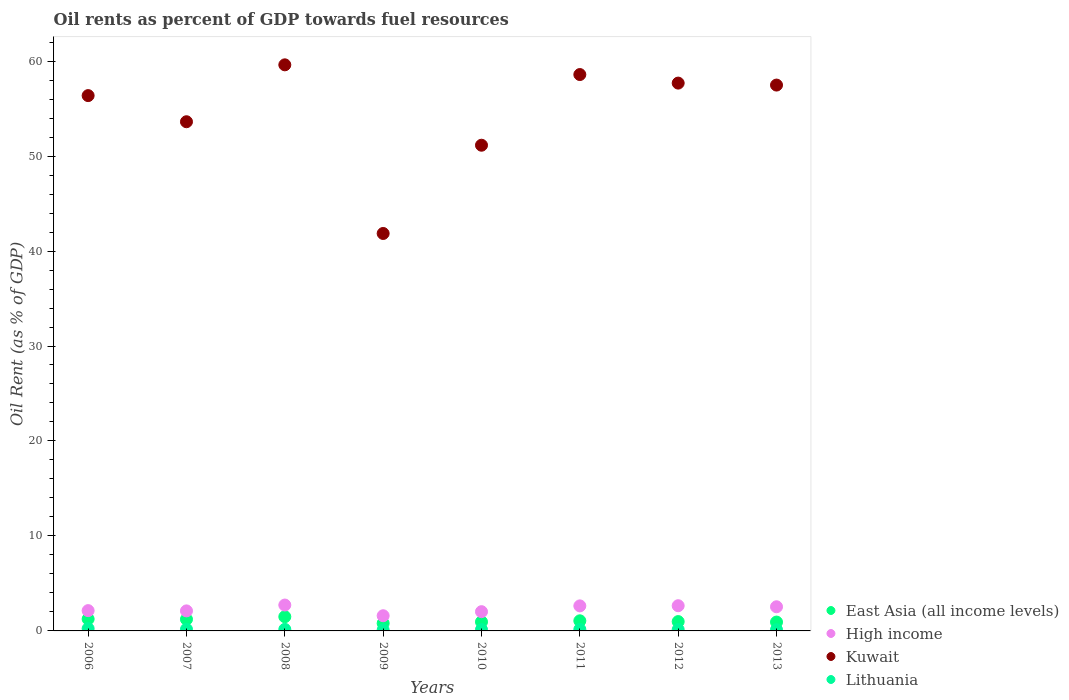Is the number of dotlines equal to the number of legend labels?
Your answer should be very brief. Yes. What is the oil rent in High income in 2010?
Your response must be concise. 2.03. Across all years, what is the maximum oil rent in East Asia (all income levels)?
Your answer should be compact. 1.5. Across all years, what is the minimum oil rent in Kuwait?
Your answer should be very brief. 41.85. In which year was the oil rent in East Asia (all income levels) maximum?
Offer a very short reply. 2008. In which year was the oil rent in Kuwait minimum?
Your answer should be very brief. 2009. What is the total oil rent in East Asia (all income levels) in the graph?
Give a very brief answer. 8.71. What is the difference between the oil rent in High income in 2008 and that in 2012?
Offer a very short reply. 0.07. What is the difference between the oil rent in East Asia (all income levels) in 2006 and the oil rent in High income in 2009?
Provide a succinct answer. -0.35. What is the average oil rent in High income per year?
Provide a succinct answer. 2.3. In the year 2008, what is the difference between the oil rent in Lithuania and oil rent in Kuwait?
Provide a short and direct response. -59.44. What is the ratio of the oil rent in High income in 2010 to that in 2011?
Your answer should be compact. 0.77. Is the oil rent in Lithuania in 2007 less than that in 2011?
Your answer should be very brief. No. What is the difference between the highest and the second highest oil rent in East Asia (all income levels)?
Provide a short and direct response. 0.24. What is the difference between the highest and the lowest oil rent in High income?
Keep it short and to the point. 1.13. Is it the case that in every year, the sum of the oil rent in Lithuania and oil rent in Kuwait  is greater than the sum of oil rent in East Asia (all income levels) and oil rent in High income?
Offer a terse response. No. Is it the case that in every year, the sum of the oil rent in East Asia (all income levels) and oil rent in Kuwait  is greater than the oil rent in Lithuania?
Ensure brevity in your answer.  Yes. Does the oil rent in Kuwait monotonically increase over the years?
Make the answer very short. No. Is the oil rent in Lithuania strictly greater than the oil rent in Kuwait over the years?
Provide a short and direct response. No. Is the oil rent in Lithuania strictly less than the oil rent in High income over the years?
Your answer should be very brief. Yes. How many dotlines are there?
Give a very brief answer. 4. How many years are there in the graph?
Offer a terse response. 8. Are the values on the major ticks of Y-axis written in scientific E-notation?
Your response must be concise. No. Does the graph contain grids?
Provide a short and direct response. No. How are the legend labels stacked?
Give a very brief answer. Vertical. What is the title of the graph?
Give a very brief answer. Oil rents as percent of GDP towards fuel resources. What is the label or title of the X-axis?
Ensure brevity in your answer.  Years. What is the label or title of the Y-axis?
Ensure brevity in your answer.  Oil Rent (as % of GDP). What is the Oil Rent (as % of GDP) in East Asia (all income levels) in 2006?
Your answer should be very brief. 1.25. What is the Oil Rent (as % of GDP) of High income in 2006?
Keep it short and to the point. 2.14. What is the Oil Rent (as % of GDP) of Kuwait in 2006?
Your answer should be compact. 56.37. What is the Oil Rent (as % of GDP) of Lithuania in 2006?
Offer a very short reply. 0.24. What is the Oil Rent (as % of GDP) in East Asia (all income levels) in 2007?
Your response must be concise. 1.22. What is the Oil Rent (as % of GDP) of High income in 2007?
Provide a short and direct response. 2.11. What is the Oil Rent (as % of GDP) in Kuwait in 2007?
Offer a very short reply. 53.61. What is the Oil Rent (as % of GDP) in Lithuania in 2007?
Your answer should be very brief. 0.17. What is the Oil Rent (as % of GDP) in East Asia (all income levels) in 2008?
Offer a very short reply. 1.5. What is the Oil Rent (as % of GDP) in High income in 2008?
Your answer should be compact. 2.73. What is the Oil Rent (as % of GDP) of Kuwait in 2008?
Your answer should be very brief. 59.61. What is the Oil Rent (as % of GDP) of Lithuania in 2008?
Offer a very short reply. 0.16. What is the Oil Rent (as % of GDP) in East Asia (all income levels) in 2009?
Offer a terse response. 0.8. What is the Oil Rent (as % of GDP) of High income in 2009?
Ensure brevity in your answer.  1.6. What is the Oil Rent (as % of GDP) of Kuwait in 2009?
Offer a very short reply. 41.85. What is the Oil Rent (as % of GDP) of Lithuania in 2009?
Offer a terse response. 0.11. What is the Oil Rent (as % of GDP) in East Asia (all income levels) in 2010?
Your response must be concise. 0.95. What is the Oil Rent (as % of GDP) in High income in 2010?
Provide a short and direct response. 2.03. What is the Oil Rent (as % of GDP) of Kuwait in 2010?
Your answer should be very brief. 51.14. What is the Oil Rent (as % of GDP) of Lithuania in 2010?
Your answer should be compact. 0.14. What is the Oil Rent (as % of GDP) of East Asia (all income levels) in 2011?
Your response must be concise. 1.07. What is the Oil Rent (as % of GDP) of High income in 2011?
Keep it short and to the point. 2.64. What is the Oil Rent (as % of GDP) of Kuwait in 2011?
Make the answer very short. 58.58. What is the Oil Rent (as % of GDP) of Lithuania in 2011?
Offer a terse response. 0.16. What is the Oil Rent (as % of GDP) of East Asia (all income levels) in 2012?
Make the answer very short. 0.98. What is the Oil Rent (as % of GDP) of High income in 2012?
Provide a succinct answer. 2.65. What is the Oil Rent (as % of GDP) of Kuwait in 2012?
Give a very brief answer. 57.68. What is the Oil Rent (as % of GDP) in Lithuania in 2012?
Your answer should be compact. 0.14. What is the Oil Rent (as % of GDP) in East Asia (all income levels) in 2013?
Your answer should be very brief. 0.93. What is the Oil Rent (as % of GDP) in High income in 2013?
Keep it short and to the point. 2.54. What is the Oil Rent (as % of GDP) in Kuwait in 2013?
Make the answer very short. 57.47. What is the Oil Rent (as % of GDP) of Lithuania in 2013?
Offer a terse response. 0.13. Across all years, what is the maximum Oil Rent (as % of GDP) in East Asia (all income levels)?
Make the answer very short. 1.5. Across all years, what is the maximum Oil Rent (as % of GDP) in High income?
Give a very brief answer. 2.73. Across all years, what is the maximum Oil Rent (as % of GDP) in Kuwait?
Offer a very short reply. 59.61. Across all years, what is the maximum Oil Rent (as % of GDP) in Lithuania?
Keep it short and to the point. 0.24. Across all years, what is the minimum Oil Rent (as % of GDP) of East Asia (all income levels)?
Your answer should be compact. 0.8. Across all years, what is the minimum Oil Rent (as % of GDP) in High income?
Provide a short and direct response. 1.6. Across all years, what is the minimum Oil Rent (as % of GDP) in Kuwait?
Make the answer very short. 41.85. Across all years, what is the minimum Oil Rent (as % of GDP) of Lithuania?
Give a very brief answer. 0.11. What is the total Oil Rent (as % of GDP) in East Asia (all income levels) in the graph?
Your answer should be very brief. 8.71. What is the total Oil Rent (as % of GDP) in High income in the graph?
Make the answer very short. 18.43. What is the total Oil Rent (as % of GDP) of Kuwait in the graph?
Offer a very short reply. 436.31. What is the total Oil Rent (as % of GDP) in Lithuania in the graph?
Offer a terse response. 1.25. What is the difference between the Oil Rent (as % of GDP) in East Asia (all income levels) in 2006 and that in 2007?
Your answer should be very brief. 0.03. What is the difference between the Oil Rent (as % of GDP) in High income in 2006 and that in 2007?
Keep it short and to the point. 0.03. What is the difference between the Oil Rent (as % of GDP) in Kuwait in 2006 and that in 2007?
Your answer should be very brief. 2.75. What is the difference between the Oil Rent (as % of GDP) in Lithuania in 2006 and that in 2007?
Provide a succinct answer. 0.07. What is the difference between the Oil Rent (as % of GDP) of East Asia (all income levels) in 2006 and that in 2008?
Provide a short and direct response. -0.24. What is the difference between the Oil Rent (as % of GDP) in High income in 2006 and that in 2008?
Offer a very short reply. -0.59. What is the difference between the Oil Rent (as % of GDP) in Kuwait in 2006 and that in 2008?
Offer a terse response. -3.24. What is the difference between the Oil Rent (as % of GDP) in Lithuania in 2006 and that in 2008?
Keep it short and to the point. 0.08. What is the difference between the Oil Rent (as % of GDP) in East Asia (all income levels) in 2006 and that in 2009?
Make the answer very short. 0.45. What is the difference between the Oil Rent (as % of GDP) of High income in 2006 and that in 2009?
Give a very brief answer. 0.54. What is the difference between the Oil Rent (as % of GDP) of Kuwait in 2006 and that in 2009?
Provide a succinct answer. 14.52. What is the difference between the Oil Rent (as % of GDP) in Lithuania in 2006 and that in 2009?
Provide a succinct answer. 0.14. What is the difference between the Oil Rent (as % of GDP) in East Asia (all income levels) in 2006 and that in 2010?
Give a very brief answer. 0.3. What is the difference between the Oil Rent (as % of GDP) of High income in 2006 and that in 2010?
Offer a terse response. 0.11. What is the difference between the Oil Rent (as % of GDP) of Kuwait in 2006 and that in 2010?
Make the answer very short. 5.22. What is the difference between the Oil Rent (as % of GDP) in Lithuania in 2006 and that in 2010?
Your answer should be very brief. 0.1. What is the difference between the Oil Rent (as % of GDP) in East Asia (all income levels) in 2006 and that in 2011?
Your answer should be compact. 0.19. What is the difference between the Oil Rent (as % of GDP) of High income in 2006 and that in 2011?
Your answer should be very brief. -0.5. What is the difference between the Oil Rent (as % of GDP) in Kuwait in 2006 and that in 2011?
Provide a succinct answer. -2.22. What is the difference between the Oil Rent (as % of GDP) of Lithuania in 2006 and that in 2011?
Offer a very short reply. 0.08. What is the difference between the Oil Rent (as % of GDP) in East Asia (all income levels) in 2006 and that in 2012?
Keep it short and to the point. 0.27. What is the difference between the Oil Rent (as % of GDP) in High income in 2006 and that in 2012?
Give a very brief answer. -0.52. What is the difference between the Oil Rent (as % of GDP) in Kuwait in 2006 and that in 2012?
Your response must be concise. -1.32. What is the difference between the Oil Rent (as % of GDP) in Lithuania in 2006 and that in 2012?
Offer a terse response. 0.1. What is the difference between the Oil Rent (as % of GDP) in East Asia (all income levels) in 2006 and that in 2013?
Your answer should be compact. 0.32. What is the difference between the Oil Rent (as % of GDP) of High income in 2006 and that in 2013?
Offer a very short reply. -0.4. What is the difference between the Oil Rent (as % of GDP) of Kuwait in 2006 and that in 2013?
Provide a short and direct response. -1.11. What is the difference between the Oil Rent (as % of GDP) of Lithuania in 2006 and that in 2013?
Give a very brief answer. 0.12. What is the difference between the Oil Rent (as % of GDP) of East Asia (all income levels) in 2007 and that in 2008?
Your answer should be very brief. -0.27. What is the difference between the Oil Rent (as % of GDP) of High income in 2007 and that in 2008?
Ensure brevity in your answer.  -0.62. What is the difference between the Oil Rent (as % of GDP) in Kuwait in 2007 and that in 2008?
Provide a succinct answer. -5.99. What is the difference between the Oil Rent (as % of GDP) in Lithuania in 2007 and that in 2008?
Make the answer very short. 0.01. What is the difference between the Oil Rent (as % of GDP) of East Asia (all income levels) in 2007 and that in 2009?
Give a very brief answer. 0.42. What is the difference between the Oil Rent (as % of GDP) in High income in 2007 and that in 2009?
Offer a terse response. 0.51. What is the difference between the Oil Rent (as % of GDP) in Kuwait in 2007 and that in 2009?
Provide a succinct answer. 11.76. What is the difference between the Oil Rent (as % of GDP) in Lithuania in 2007 and that in 2009?
Make the answer very short. 0.07. What is the difference between the Oil Rent (as % of GDP) in East Asia (all income levels) in 2007 and that in 2010?
Make the answer very short. 0.27. What is the difference between the Oil Rent (as % of GDP) of High income in 2007 and that in 2010?
Your answer should be compact. 0.08. What is the difference between the Oil Rent (as % of GDP) of Kuwait in 2007 and that in 2010?
Keep it short and to the point. 2.47. What is the difference between the Oil Rent (as % of GDP) in Lithuania in 2007 and that in 2010?
Offer a terse response. 0.03. What is the difference between the Oil Rent (as % of GDP) of East Asia (all income levels) in 2007 and that in 2011?
Make the answer very short. 0.16. What is the difference between the Oil Rent (as % of GDP) of High income in 2007 and that in 2011?
Offer a very short reply. -0.53. What is the difference between the Oil Rent (as % of GDP) in Kuwait in 2007 and that in 2011?
Keep it short and to the point. -4.97. What is the difference between the Oil Rent (as % of GDP) in Lithuania in 2007 and that in 2011?
Keep it short and to the point. 0.01. What is the difference between the Oil Rent (as % of GDP) of East Asia (all income levels) in 2007 and that in 2012?
Your answer should be compact. 0.24. What is the difference between the Oil Rent (as % of GDP) in High income in 2007 and that in 2012?
Make the answer very short. -0.54. What is the difference between the Oil Rent (as % of GDP) in Kuwait in 2007 and that in 2012?
Provide a short and direct response. -4.07. What is the difference between the Oil Rent (as % of GDP) in Lithuania in 2007 and that in 2012?
Ensure brevity in your answer.  0.03. What is the difference between the Oil Rent (as % of GDP) in East Asia (all income levels) in 2007 and that in 2013?
Keep it short and to the point. 0.29. What is the difference between the Oil Rent (as % of GDP) of High income in 2007 and that in 2013?
Offer a terse response. -0.43. What is the difference between the Oil Rent (as % of GDP) in Kuwait in 2007 and that in 2013?
Your answer should be compact. -3.86. What is the difference between the Oil Rent (as % of GDP) of Lithuania in 2007 and that in 2013?
Make the answer very short. 0.05. What is the difference between the Oil Rent (as % of GDP) in East Asia (all income levels) in 2008 and that in 2009?
Give a very brief answer. 0.69. What is the difference between the Oil Rent (as % of GDP) in High income in 2008 and that in 2009?
Give a very brief answer. 1.13. What is the difference between the Oil Rent (as % of GDP) of Kuwait in 2008 and that in 2009?
Provide a short and direct response. 17.76. What is the difference between the Oil Rent (as % of GDP) of Lithuania in 2008 and that in 2009?
Your answer should be very brief. 0.06. What is the difference between the Oil Rent (as % of GDP) in East Asia (all income levels) in 2008 and that in 2010?
Offer a very short reply. 0.54. What is the difference between the Oil Rent (as % of GDP) of High income in 2008 and that in 2010?
Offer a terse response. 0.7. What is the difference between the Oil Rent (as % of GDP) of Kuwait in 2008 and that in 2010?
Your answer should be compact. 8.46. What is the difference between the Oil Rent (as % of GDP) of Lithuania in 2008 and that in 2010?
Your answer should be very brief. 0.02. What is the difference between the Oil Rent (as % of GDP) in East Asia (all income levels) in 2008 and that in 2011?
Keep it short and to the point. 0.43. What is the difference between the Oil Rent (as % of GDP) in High income in 2008 and that in 2011?
Your answer should be compact. 0.09. What is the difference between the Oil Rent (as % of GDP) in Kuwait in 2008 and that in 2011?
Your response must be concise. 1.02. What is the difference between the Oil Rent (as % of GDP) in Lithuania in 2008 and that in 2011?
Your answer should be compact. 0. What is the difference between the Oil Rent (as % of GDP) of East Asia (all income levels) in 2008 and that in 2012?
Your answer should be very brief. 0.51. What is the difference between the Oil Rent (as % of GDP) of High income in 2008 and that in 2012?
Ensure brevity in your answer.  0.07. What is the difference between the Oil Rent (as % of GDP) of Kuwait in 2008 and that in 2012?
Your answer should be compact. 1.92. What is the difference between the Oil Rent (as % of GDP) of Lithuania in 2008 and that in 2012?
Ensure brevity in your answer.  0.02. What is the difference between the Oil Rent (as % of GDP) in East Asia (all income levels) in 2008 and that in 2013?
Your response must be concise. 0.56. What is the difference between the Oil Rent (as % of GDP) of High income in 2008 and that in 2013?
Give a very brief answer. 0.18. What is the difference between the Oil Rent (as % of GDP) in Kuwait in 2008 and that in 2013?
Your answer should be compact. 2.13. What is the difference between the Oil Rent (as % of GDP) in Lithuania in 2008 and that in 2013?
Ensure brevity in your answer.  0.04. What is the difference between the Oil Rent (as % of GDP) of East Asia (all income levels) in 2009 and that in 2010?
Make the answer very short. -0.15. What is the difference between the Oil Rent (as % of GDP) of High income in 2009 and that in 2010?
Ensure brevity in your answer.  -0.43. What is the difference between the Oil Rent (as % of GDP) in Kuwait in 2009 and that in 2010?
Ensure brevity in your answer.  -9.29. What is the difference between the Oil Rent (as % of GDP) in Lithuania in 2009 and that in 2010?
Your answer should be very brief. -0.04. What is the difference between the Oil Rent (as % of GDP) of East Asia (all income levels) in 2009 and that in 2011?
Make the answer very short. -0.26. What is the difference between the Oil Rent (as % of GDP) of High income in 2009 and that in 2011?
Your response must be concise. -1.04. What is the difference between the Oil Rent (as % of GDP) of Kuwait in 2009 and that in 2011?
Provide a short and direct response. -16.73. What is the difference between the Oil Rent (as % of GDP) in Lithuania in 2009 and that in 2011?
Provide a short and direct response. -0.06. What is the difference between the Oil Rent (as % of GDP) in East Asia (all income levels) in 2009 and that in 2012?
Make the answer very short. -0.18. What is the difference between the Oil Rent (as % of GDP) of High income in 2009 and that in 2012?
Keep it short and to the point. -1.05. What is the difference between the Oil Rent (as % of GDP) in Kuwait in 2009 and that in 2012?
Your answer should be compact. -15.83. What is the difference between the Oil Rent (as % of GDP) of Lithuania in 2009 and that in 2012?
Keep it short and to the point. -0.04. What is the difference between the Oil Rent (as % of GDP) in East Asia (all income levels) in 2009 and that in 2013?
Ensure brevity in your answer.  -0.13. What is the difference between the Oil Rent (as % of GDP) of High income in 2009 and that in 2013?
Provide a short and direct response. -0.94. What is the difference between the Oil Rent (as % of GDP) of Kuwait in 2009 and that in 2013?
Ensure brevity in your answer.  -15.63. What is the difference between the Oil Rent (as % of GDP) of Lithuania in 2009 and that in 2013?
Give a very brief answer. -0.02. What is the difference between the Oil Rent (as % of GDP) of East Asia (all income levels) in 2010 and that in 2011?
Your answer should be compact. -0.11. What is the difference between the Oil Rent (as % of GDP) of High income in 2010 and that in 2011?
Keep it short and to the point. -0.61. What is the difference between the Oil Rent (as % of GDP) of Kuwait in 2010 and that in 2011?
Give a very brief answer. -7.44. What is the difference between the Oil Rent (as % of GDP) in Lithuania in 2010 and that in 2011?
Keep it short and to the point. -0.02. What is the difference between the Oil Rent (as % of GDP) in East Asia (all income levels) in 2010 and that in 2012?
Make the answer very short. -0.03. What is the difference between the Oil Rent (as % of GDP) in High income in 2010 and that in 2012?
Provide a short and direct response. -0.63. What is the difference between the Oil Rent (as % of GDP) of Kuwait in 2010 and that in 2012?
Provide a succinct answer. -6.54. What is the difference between the Oil Rent (as % of GDP) in Lithuania in 2010 and that in 2012?
Keep it short and to the point. -0. What is the difference between the Oil Rent (as % of GDP) of East Asia (all income levels) in 2010 and that in 2013?
Your answer should be compact. 0.02. What is the difference between the Oil Rent (as % of GDP) of High income in 2010 and that in 2013?
Your answer should be compact. -0.52. What is the difference between the Oil Rent (as % of GDP) in Kuwait in 2010 and that in 2013?
Your answer should be very brief. -6.33. What is the difference between the Oil Rent (as % of GDP) of Lithuania in 2010 and that in 2013?
Provide a succinct answer. 0.02. What is the difference between the Oil Rent (as % of GDP) of East Asia (all income levels) in 2011 and that in 2012?
Give a very brief answer. 0.08. What is the difference between the Oil Rent (as % of GDP) of High income in 2011 and that in 2012?
Provide a short and direct response. -0.02. What is the difference between the Oil Rent (as % of GDP) in Kuwait in 2011 and that in 2012?
Keep it short and to the point. 0.9. What is the difference between the Oil Rent (as % of GDP) of Lithuania in 2011 and that in 2012?
Offer a very short reply. 0.02. What is the difference between the Oil Rent (as % of GDP) of East Asia (all income levels) in 2011 and that in 2013?
Provide a short and direct response. 0.13. What is the difference between the Oil Rent (as % of GDP) of High income in 2011 and that in 2013?
Ensure brevity in your answer.  0.09. What is the difference between the Oil Rent (as % of GDP) in Kuwait in 2011 and that in 2013?
Make the answer very short. 1.11. What is the difference between the Oil Rent (as % of GDP) in Lithuania in 2011 and that in 2013?
Offer a terse response. 0.04. What is the difference between the Oil Rent (as % of GDP) in East Asia (all income levels) in 2012 and that in 2013?
Provide a succinct answer. 0.05. What is the difference between the Oil Rent (as % of GDP) of High income in 2012 and that in 2013?
Provide a succinct answer. 0.11. What is the difference between the Oil Rent (as % of GDP) in Kuwait in 2012 and that in 2013?
Give a very brief answer. 0.21. What is the difference between the Oil Rent (as % of GDP) of Lithuania in 2012 and that in 2013?
Offer a very short reply. 0.02. What is the difference between the Oil Rent (as % of GDP) of East Asia (all income levels) in 2006 and the Oil Rent (as % of GDP) of High income in 2007?
Offer a terse response. -0.86. What is the difference between the Oil Rent (as % of GDP) of East Asia (all income levels) in 2006 and the Oil Rent (as % of GDP) of Kuwait in 2007?
Provide a succinct answer. -52.36. What is the difference between the Oil Rent (as % of GDP) in East Asia (all income levels) in 2006 and the Oil Rent (as % of GDP) in Lithuania in 2007?
Ensure brevity in your answer.  1.08. What is the difference between the Oil Rent (as % of GDP) in High income in 2006 and the Oil Rent (as % of GDP) in Kuwait in 2007?
Ensure brevity in your answer.  -51.48. What is the difference between the Oil Rent (as % of GDP) of High income in 2006 and the Oil Rent (as % of GDP) of Lithuania in 2007?
Keep it short and to the point. 1.97. What is the difference between the Oil Rent (as % of GDP) in Kuwait in 2006 and the Oil Rent (as % of GDP) in Lithuania in 2007?
Provide a succinct answer. 56.19. What is the difference between the Oil Rent (as % of GDP) of East Asia (all income levels) in 2006 and the Oil Rent (as % of GDP) of High income in 2008?
Your answer should be compact. -1.47. What is the difference between the Oil Rent (as % of GDP) in East Asia (all income levels) in 2006 and the Oil Rent (as % of GDP) in Kuwait in 2008?
Make the answer very short. -58.35. What is the difference between the Oil Rent (as % of GDP) of East Asia (all income levels) in 2006 and the Oil Rent (as % of GDP) of Lithuania in 2008?
Your answer should be very brief. 1.09. What is the difference between the Oil Rent (as % of GDP) of High income in 2006 and the Oil Rent (as % of GDP) of Kuwait in 2008?
Make the answer very short. -57.47. What is the difference between the Oil Rent (as % of GDP) in High income in 2006 and the Oil Rent (as % of GDP) in Lithuania in 2008?
Give a very brief answer. 1.97. What is the difference between the Oil Rent (as % of GDP) of Kuwait in 2006 and the Oil Rent (as % of GDP) of Lithuania in 2008?
Provide a short and direct response. 56.2. What is the difference between the Oil Rent (as % of GDP) of East Asia (all income levels) in 2006 and the Oil Rent (as % of GDP) of High income in 2009?
Provide a succinct answer. -0.35. What is the difference between the Oil Rent (as % of GDP) in East Asia (all income levels) in 2006 and the Oil Rent (as % of GDP) in Kuwait in 2009?
Your response must be concise. -40.6. What is the difference between the Oil Rent (as % of GDP) in East Asia (all income levels) in 2006 and the Oil Rent (as % of GDP) in Lithuania in 2009?
Offer a terse response. 1.15. What is the difference between the Oil Rent (as % of GDP) in High income in 2006 and the Oil Rent (as % of GDP) in Kuwait in 2009?
Make the answer very short. -39.71. What is the difference between the Oil Rent (as % of GDP) of High income in 2006 and the Oil Rent (as % of GDP) of Lithuania in 2009?
Give a very brief answer. 2.03. What is the difference between the Oil Rent (as % of GDP) in Kuwait in 2006 and the Oil Rent (as % of GDP) in Lithuania in 2009?
Keep it short and to the point. 56.26. What is the difference between the Oil Rent (as % of GDP) of East Asia (all income levels) in 2006 and the Oil Rent (as % of GDP) of High income in 2010?
Provide a succinct answer. -0.77. What is the difference between the Oil Rent (as % of GDP) of East Asia (all income levels) in 2006 and the Oil Rent (as % of GDP) of Kuwait in 2010?
Provide a short and direct response. -49.89. What is the difference between the Oil Rent (as % of GDP) of East Asia (all income levels) in 2006 and the Oil Rent (as % of GDP) of Lithuania in 2010?
Provide a succinct answer. 1.11. What is the difference between the Oil Rent (as % of GDP) in High income in 2006 and the Oil Rent (as % of GDP) in Kuwait in 2010?
Give a very brief answer. -49. What is the difference between the Oil Rent (as % of GDP) of High income in 2006 and the Oil Rent (as % of GDP) of Lithuania in 2010?
Offer a very short reply. 2. What is the difference between the Oil Rent (as % of GDP) in Kuwait in 2006 and the Oil Rent (as % of GDP) in Lithuania in 2010?
Your answer should be compact. 56.22. What is the difference between the Oil Rent (as % of GDP) of East Asia (all income levels) in 2006 and the Oil Rent (as % of GDP) of High income in 2011?
Your answer should be very brief. -1.38. What is the difference between the Oil Rent (as % of GDP) of East Asia (all income levels) in 2006 and the Oil Rent (as % of GDP) of Kuwait in 2011?
Keep it short and to the point. -57.33. What is the difference between the Oil Rent (as % of GDP) of East Asia (all income levels) in 2006 and the Oil Rent (as % of GDP) of Lithuania in 2011?
Your answer should be compact. 1.09. What is the difference between the Oil Rent (as % of GDP) of High income in 2006 and the Oil Rent (as % of GDP) of Kuwait in 2011?
Offer a very short reply. -56.45. What is the difference between the Oil Rent (as % of GDP) of High income in 2006 and the Oil Rent (as % of GDP) of Lithuania in 2011?
Provide a short and direct response. 1.98. What is the difference between the Oil Rent (as % of GDP) of Kuwait in 2006 and the Oil Rent (as % of GDP) of Lithuania in 2011?
Make the answer very short. 56.2. What is the difference between the Oil Rent (as % of GDP) of East Asia (all income levels) in 2006 and the Oil Rent (as % of GDP) of High income in 2012?
Offer a terse response. -1.4. What is the difference between the Oil Rent (as % of GDP) in East Asia (all income levels) in 2006 and the Oil Rent (as % of GDP) in Kuwait in 2012?
Ensure brevity in your answer.  -56.43. What is the difference between the Oil Rent (as % of GDP) in East Asia (all income levels) in 2006 and the Oil Rent (as % of GDP) in Lithuania in 2012?
Offer a very short reply. 1.11. What is the difference between the Oil Rent (as % of GDP) of High income in 2006 and the Oil Rent (as % of GDP) of Kuwait in 2012?
Your answer should be very brief. -55.54. What is the difference between the Oil Rent (as % of GDP) in High income in 2006 and the Oil Rent (as % of GDP) in Lithuania in 2012?
Your answer should be compact. 2. What is the difference between the Oil Rent (as % of GDP) of Kuwait in 2006 and the Oil Rent (as % of GDP) of Lithuania in 2012?
Give a very brief answer. 56.22. What is the difference between the Oil Rent (as % of GDP) in East Asia (all income levels) in 2006 and the Oil Rent (as % of GDP) in High income in 2013?
Keep it short and to the point. -1.29. What is the difference between the Oil Rent (as % of GDP) in East Asia (all income levels) in 2006 and the Oil Rent (as % of GDP) in Kuwait in 2013?
Keep it short and to the point. -56.22. What is the difference between the Oil Rent (as % of GDP) in East Asia (all income levels) in 2006 and the Oil Rent (as % of GDP) in Lithuania in 2013?
Keep it short and to the point. 1.13. What is the difference between the Oil Rent (as % of GDP) in High income in 2006 and the Oil Rent (as % of GDP) in Kuwait in 2013?
Your answer should be compact. -55.34. What is the difference between the Oil Rent (as % of GDP) of High income in 2006 and the Oil Rent (as % of GDP) of Lithuania in 2013?
Your answer should be very brief. 2.01. What is the difference between the Oil Rent (as % of GDP) of Kuwait in 2006 and the Oil Rent (as % of GDP) of Lithuania in 2013?
Your answer should be compact. 56.24. What is the difference between the Oil Rent (as % of GDP) of East Asia (all income levels) in 2007 and the Oil Rent (as % of GDP) of High income in 2008?
Make the answer very short. -1.5. What is the difference between the Oil Rent (as % of GDP) in East Asia (all income levels) in 2007 and the Oil Rent (as % of GDP) in Kuwait in 2008?
Keep it short and to the point. -58.38. What is the difference between the Oil Rent (as % of GDP) in East Asia (all income levels) in 2007 and the Oil Rent (as % of GDP) in Lithuania in 2008?
Offer a very short reply. 1.06. What is the difference between the Oil Rent (as % of GDP) in High income in 2007 and the Oil Rent (as % of GDP) in Kuwait in 2008?
Provide a short and direct response. -57.5. What is the difference between the Oil Rent (as % of GDP) in High income in 2007 and the Oil Rent (as % of GDP) in Lithuania in 2008?
Ensure brevity in your answer.  1.95. What is the difference between the Oil Rent (as % of GDP) in Kuwait in 2007 and the Oil Rent (as % of GDP) in Lithuania in 2008?
Keep it short and to the point. 53.45. What is the difference between the Oil Rent (as % of GDP) of East Asia (all income levels) in 2007 and the Oil Rent (as % of GDP) of High income in 2009?
Give a very brief answer. -0.37. What is the difference between the Oil Rent (as % of GDP) in East Asia (all income levels) in 2007 and the Oil Rent (as % of GDP) in Kuwait in 2009?
Offer a very short reply. -40.62. What is the difference between the Oil Rent (as % of GDP) in East Asia (all income levels) in 2007 and the Oil Rent (as % of GDP) in Lithuania in 2009?
Make the answer very short. 1.12. What is the difference between the Oil Rent (as % of GDP) in High income in 2007 and the Oil Rent (as % of GDP) in Kuwait in 2009?
Give a very brief answer. -39.74. What is the difference between the Oil Rent (as % of GDP) in High income in 2007 and the Oil Rent (as % of GDP) in Lithuania in 2009?
Provide a succinct answer. 2. What is the difference between the Oil Rent (as % of GDP) of Kuwait in 2007 and the Oil Rent (as % of GDP) of Lithuania in 2009?
Offer a very short reply. 53.51. What is the difference between the Oil Rent (as % of GDP) of East Asia (all income levels) in 2007 and the Oil Rent (as % of GDP) of High income in 2010?
Keep it short and to the point. -0.8. What is the difference between the Oil Rent (as % of GDP) in East Asia (all income levels) in 2007 and the Oil Rent (as % of GDP) in Kuwait in 2010?
Make the answer very short. -49.92. What is the difference between the Oil Rent (as % of GDP) of East Asia (all income levels) in 2007 and the Oil Rent (as % of GDP) of Lithuania in 2010?
Keep it short and to the point. 1.08. What is the difference between the Oil Rent (as % of GDP) of High income in 2007 and the Oil Rent (as % of GDP) of Kuwait in 2010?
Ensure brevity in your answer.  -49.03. What is the difference between the Oil Rent (as % of GDP) of High income in 2007 and the Oil Rent (as % of GDP) of Lithuania in 2010?
Offer a terse response. 1.97. What is the difference between the Oil Rent (as % of GDP) in Kuwait in 2007 and the Oil Rent (as % of GDP) in Lithuania in 2010?
Keep it short and to the point. 53.47. What is the difference between the Oil Rent (as % of GDP) in East Asia (all income levels) in 2007 and the Oil Rent (as % of GDP) in High income in 2011?
Ensure brevity in your answer.  -1.41. What is the difference between the Oil Rent (as % of GDP) in East Asia (all income levels) in 2007 and the Oil Rent (as % of GDP) in Kuwait in 2011?
Offer a terse response. -57.36. What is the difference between the Oil Rent (as % of GDP) in East Asia (all income levels) in 2007 and the Oil Rent (as % of GDP) in Lithuania in 2011?
Your answer should be compact. 1.06. What is the difference between the Oil Rent (as % of GDP) of High income in 2007 and the Oil Rent (as % of GDP) of Kuwait in 2011?
Provide a short and direct response. -56.47. What is the difference between the Oil Rent (as % of GDP) in High income in 2007 and the Oil Rent (as % of GDP) in Lithuania in 2011?
Provide a succinct answer. 1.95. What is the difference between the Oil Rent (as % of GDP) of Kuwait in 2007 and the Oil Rent (as % of GDP) of Lithuania in 2011?
Provide a succinct answer. 53.45. What is the difference between the Oil Rent (as % of GDP) in East Asia (all income levels) in 2007 and the Oil Rent (as % of GDP) in High income in 2012?
Provide a short and direct response. -1.43. What is the difference between the Oil Rent (as % of GDP) of East Asia (all income levels) in 2007 and the Oil Rent (as % of GDP) of Kuwait in 2012?
Your answer should be compact. -56.46. What is the difference between the Oil Rent (as % of GDP) of East Asia (all income levels) in 2007 and the Oil Rent (as % of GDP) of Lithuania in 2012?
Offer a very short reply. 1.08. What is the difference between the Oil Rent (as % of GDP) of High income in 2007 and the Oil Rent (as % of GDP) of Kuwait in 2012?
Offer a very short reply. -55.57. What is the difference between the Oil Rent (as % of GDP) of High income in 2007 and the Oil Rent (as % of GDP) of Lithuania in 2012?
Provide a succinct answer. 1.97. What is the difference between the Oil Rent (as % of GDP) in Kuwait in 2007 and the Oil Rent (as % of GDP) in Lithuania in 2012?
Your response must be concise. 53.47. What is the difference between the Oil Rent (as % of GDP) of East Asia (all income levels) in 2007 and the Oil Rent (as % of GDP) of High income in 2013?
Keep it short and to the point. -1.32. What is the difference between the Oil Rent (as % of GDP) in East Asia (all income levels) in 2007 and the Oil Rent (as % of GDP) in Kuwait in 2013?
Ensure brevity in your answer.  -56.25. What is the difference between the Oil Rent (as % of GDP) of East Asia (all income levels) in 2007 and the Oil Rent (as % of GDP) of Lithuania in 2013?
Your answer should be compact. 1.1. What is the difference between the Oil Rent (as % of GDP) in High income in 2007 and the Oil Rent (as % of GDP) in Kuwait in 2013?
Provide a short and direct response. -55.36. What is the difference between the Oil Rent (as % of GDP) in High income in 2007 and the Oil Rent (as % of GDP) in Lithuania in 2013?
Keep it short and to the point. 1.98. What is the difference between the Oil Rent (as % of GDP) of Kuwait in 2007 and the Oil Rent (as % of GDP) of Lithuania in 2013?
Your response must be concise. 53.49. What is the difference between the Oil Rent (as % of GDP) in East Asia (all income levels) in 2008 and the Oil Rent (as % of GDP) in High income in 2009?
Your response must be concise. -0.1. What is the difference between the Oil Rent (as % of GDP) of East Asia (all income levels) in 2008 and the Oil Rent (as % of GDP) of Kuwait in 2009?
Provide a succinct answer. -40.35. What is the difference between the Oil Rent (as % of GDP) in East Asia (all income levels) in 2008 and the Oil Rent (as % of GDP) in Lithuania in 2009?
Your response must be concise. 1.39. What is the difference between the Oil Rent (as % of GDP) in High income in 2008 and the Oil Rent (as % of GDP) in Kuwait in 2009?
Ensure brevity in your answer.  -39.12. What is the difference between the Oil Rent (as % of GDP) in High income in 2008 and the Oil Rent (as % of GDP) in Lithuania in 2009?
Your answer should be compact. 2.62. What is the difference between the Oil Rent (as % of GDP) in Kuwait in 2008 and the Oil Rent (as % of GDP) in Lithuania in 2009?
Provide a short and direct response. 59.5. What is the difference between the Oil Rent (as % of GDP) in East Asia (all income levels) in 2008 and the Oil Rent (as % of GDP) in High income in 2010?
Your response must be concise. -0.53. What is the difference between the Oil Rent (as % of GDP) of East Asia (all income levels) in 2008 and the Oil Rent (as % of GDP) of Kuwait in 2010?
Your answer should be compact. -49.65. What is the difference between the Oil Rent (as % of GDP) in East Asia (all income levels) in 2008 and the Oil Rent (as % of GDP) in Lithuania in 2010?
Provide a short and direct response. 1.35. What is the difference between the Oil Rent (as % of GDP) in High income in 2008 and the Oil Rent (as % of GDP) in Kuwait in 2010?
Offer a very short reply. -48.42. What is the difference between the Oil Rent (as % of GDP) in High income in 2008 and the Oil Rent (as % of GDP) in Lithuania in 2010?
Keep it short and to the point. 2.58. What is the difference between the Oil Rent (as % of GDP) in Kuwait in 2008 and the Oil Rent (as % of GDP) in Lithuania in 2010?
Your response must be concise. 59.46. What is the difference between the Oil Rent (as % of GDP) in East Asia (all income levels) in 2008 and the Oil Rent (as % of GDP) in High income in 2011?
Your answer should be very brief. -1.14. What is the difference between the Oil Rent (as % of GDP) of East Asia (all income levels) in 2008 and the Oil Rent (as % of GDP) of Kuwait in 2011?
Your answer should be very brief. -57.09. What is the difference between the Oil Rent (as % of GDP) in East Asia (all income levels) in 2008 and the Oil Rent (as % of GDP) in Lithuania in 2011?
Make the answer very short. 1.33. What is the difference between the Oil Rent (as % of GDP) of High income in 2008 and the Oil Rent (as % of GDP) of Kuwait in 2011?
Offer a terse response. -55.86. What is the difference between the Oil Rent (as % of GDP) in High income in 2008 and the Oil Rent (as % of GDP) in Lithuania in 2011?
Give a very brief answer. 2.56. What is the difference between the Oil Rent (as % of GDP) of Kuwait in 2008 and the Oil Rent (as % of GDP) of Lithuania in 2011?
Offer a terse response. 59.45. What is the difference between the Oil Rent (as % of GDP) in East Asia (all income levels) in 2008 and the Oil Rent (as % of GDP) in High income in 2012?
Ensure brevity in your answer.  -1.16. What is the difference between the Oil Rent (as % of GDP) in East Asia (all income levels) in 2008 and the Oil Rent (as % of GDP) in Kuwait in 2012?
Provide a succinct answer. -56.19. What is the difference between the Oil Rent (as % of GDP) in East Asia (all income levels) in 2008 and the Oil Rent (as % of GDP) in Lithuania in 2012?
Your answer should be very brief. 1.35. What is the difference between the Oil Rent (as % of GDP) in High income in 2008 and the Oil Rent (as % of GDP) in Kuwait in 2012?
Provide a short and direct response. -54.96. What is the difference between the Oil Rent (as % of GDP) in High income in 2008 and the Oil Rent (as % of GDP) in Lithuania in 2012?
Offer a terse response. 2.58. What is the difference between the Oil Rent (as % of GDP) in Kuwait in 2008 and the Oil Rent (as % of GDP) in Lithuania in 2012?
Ensure brevity in your answer.  59.46. What is the difference between the Oil Rent (as % of GDP) of East Asia (all income levels) in 2008 and the Oil Rent (as % of GDP) of High income in 2013?
Make the answer very short. -1.05. What is the difference between the Oil Rent (as % of GDP) of East Asia (all income levels) in 2008 and the Oil Rent (as % of GDP) of Kuwait in 2013?
Give a very brief answer. -55.98. What is the difference between the Oil Rent (as % of GDP) of East Asia (all income levels) in 2008 and the Oil Rent (as % of GDP) of Lithuania in 2013?
Your answer should be compact. 1.37. What is the difference between the Oil Rent (as % of GDP) of High income in 2008 and the Oil Rent (as % of GDP) of Kuwait in 2013?
Provide a short and direct response. -54.75. What is the difference between the Oil Rent (as % of GDP) in High income in 2008 and the Oil Rent (as % of GDP) in Lithuania in 2013?
Offer a very short reply. 2.6. What is the difference between the Oil Rent (as % of GDP) in Kuwait in 2008 and the Oil Rent (as % of GDP) in Lithuania in 2013?
Ensure brevity in your answer.  59.48. What is the difference between the Oil Rent (as % of GDP) in East Asia (all income levels) in 2009 and the Oil Rent (as % of GDP) in High income in 2010?
Give a very brief answer. -1.22. What is the difference between the Oil Rent (as % of GDP) in East Asia (all income levels) in 2009 and the Oil Rent (as % of GDP) in Kuwait in 2010?
Provide a short and direct response. -50.34. What is the difference between the Oil Rent (as % of GDP) in East Asia (all income levels) in 2009 and the Oil Rent (as % of GDP) in Lithuania in 2010?
Your response must be concise. 0.66. What is the difference between the Oil Rent (as % of GDP) of High income in 2009 and the Oil Rent (as % of GDP) of Kuwait in 2010?
Offer a terse response. -49.54. What is the difference between the Oil Rent (as % of GDP) in High income in 2009 and the Oil Rent (as % of GDP) in Lithuania in 2010?
Your answer should be very brief. 1.46. What is the difference between the Oil Rent (as % of GDP) in Kuwait in 2009 and the Oil Rent (as % of GDP) in Lithuania in 2010?
Your answer should be compact. 41.71. What is the difference between the Oil Rent (as % of GDP) of East Asia (all income levels) in 2009 and the Oil Rent (as % of GDP) of High income in 2011?
Provide a succinct answer. -1.83. What is the difference between the Oil Rent (as % of GDP) of East Asia (all income levels) in 2009 and the Oil Rent (as % of GDP) of Kuwait in 2011?
Keep it short and to the point. -57.78. What is the difference between the Oil Rent (as % of GDP) of East Asia (all income levels) in 2009 and the Oil Rent (as % of GDP) of Lithuania in 2011?
Give a very brief answer. 0.64. What is the difference between the Oil Rent (as % of GDP) in High income in 2009 and the Oil Rent (as % of GDP) in Kuwait in 2011?
Provide a succinct answer. -56.98. What is the difference between the Oil Rent (as % of GDP) in High income in 2009 and the Oil Rent (as % of GDP) in Lithuania in 2011?
Ensure brevity in your answer.  1.44. What is the difference between the Oil Rent (as % of GDP) of Kuwait in 2009 and the Oil Rent (as % of GDP) of Lithuania in 2011?
Give a very brief answer. 41.69. What is the difference between the Oil Rent (as % of GDP) of East Asia (all income levels) in 2009 and the Oil Rent (as % of GDP) of High income in 2012?
Provide a succinct answer. -1.85. What is the difference between the Oil Rent (as % of GDP) in East Asia (all income levels) in 2009 and the Oil Rent (as % of GDP) in Kuwait in 2012?
Keep it short and to the point. -56.88. What is the difference between the Oil Rent (as % of GDP) of East Asia (all income levels) in 2009 and the Oil Rent (as % of GDP) of Lithuania in 2012?
Your answer should be very brief. 0.66. What is the difference between the Oil Rent (as % of GDP) in High income in 2009 and the Oil Rent (as % of GDP) in Kuwait in 2012?
Your answer should be very brief. -56.08. What is the difference between the Oil Rent (as % of GDP) of High income in 2009 and the Oil Rent (as % of GDP) of Lithuania in 2012?
Provide a succinct answer. 1.46. What is the difference between the Oil Rent (as % of GDP) of Kuwait in 2009 and the Oil Rent (as % of GDP) of Lithuania in 2012?
Make the answer very short. 41.71. What is the difference between the Oil Rent (as % of GDP) of East Asia (all income levels) in 2009 and the Oil Rent (as % of GDP) of High income in 2013?
Your response must be concise. -1.74. What is the difference between the Oil Rent (as % of GDP) in East Asia (all income levels) in 2009 and the Oil Rent (as % of GDP) in Kuwait in 2013?
Keep it short and to the point. -56.67. What is the difference between the Oil Rent (as % of GDP) of East Asia (all income levels) in 2009 and the Oil Rent (as % of GDP) of Lithuania in 2013?
Provide a short and direct response. 0.68. What is the difference between the Oil Rent (as % of GDP) of High income in 2009 and the Oil Rent (as % of GDP) of Kuwait in 2013?
Provide a short and direct response. -55.88. What is the difference between the Oil Rent (as % of GDP) of High income in 2009 and the Oil Rent (as % of GDP) of Lithuania in 2013?
Provide a short and direct response. 1.47. What is the difference between the Oil Rent (as % of GDP) in Kuwait in 2009 and the Oil Rent (as % of GDP) in Lithuania in 2013?
Offer a very short reply. 41.72. What is the difference between the Oil Rent (as % of GDP) in East Asia (all income levels) in 2010 and the Oil Rent (as % of GDP) in High income in 2011?
Your response must be concise. -1.69. What is the difference between the Oil Rent (as % of GDP) in East Asia (all income levels) in 2010 and the Oil Rent (as % of GDP) in Kuwait in 2011?
Your answer should be compact. -57.63. What is the difference between the Oil Rent (as % of GDP) of East Asia (all income levels) in 2010 and the Oil Rent (as % of GDP) of Lithuania in 2011?
Give a very brief answer. 0.79. What is the difference between the Oil Rent (as % of GDP) of High income in 2010 and the Oil Rent (as % of GDP) of Kuwait in 2011?
Keep it short and to the point. -56.56. What is the difference between the Oil Rent (as % of GDP) of High income in 2010 and the Oil Rent (as % of GDP) of Lithuania in 2011?
Give a very brief answer. 1.86. What is the difference between the Oil Rent (as % of GDP) of Kuwait in 2010 and the Oil Rent (as % of GDP) of Lithuania in 2011?
Ensure brevity in your answer.  50.98. What is the difference between the Oil Rent (as % of GDP) of East Asia (all income levels) in 2010 and the Oil Rent (as % of GDP) of High income in 2012?
Your answer should be very brief. -1.7. What is the difference between the Oil Rent (as % of GDP) in East Asia (all income levels) in 2010 and the Oil Rent (as % of GDP) in Kuwait in 2012?
Offer a very short reply. -56.73. What is the difference between the Oil Rent (as % of GDP) in East Asia (all income levels) in 2010 and the Oil Rent (as % of GDP) in Lithuania in 2012?
Offer a very short reply. 0.81. What is the difference between the Oil Rent (as % of GDP) of High income in 2010 and the Oil Rent (as % of GDP) of Kuwait in 2012?
Provide a succinct answer. -55.66. What is the difference between the Oil Rent (as % of GDP) of High income in 2010 and the Oil Rent (as % of GDP) of Lithuania in 2012?
Provide a succinct answer. 1.88. What is the difference between the Oil Rent (as % of GDP) in Kuwait in 2010 and the Oil Rent (as % of GDP) in Lithuania in 2012?
Provide a short and direct response. 51. What is the difference between the Oil Rent (as % of GDP) in East Asia (all income levels) in 2010 and the Oil Rent (as % of GDP) in High income in 2013?
Give a very brief answer. -1.59. What is the difference between the Oil Rent (as % of GDP) of East Asia (all income levels) in 2010 and the Oil Rent (as % of GDP) of Kuwait in 2013?
Provide a short and direct response. -56.52. What is the difference between the Oil Rent (as % of GDP) in East Asia (all income levels) in 2010 and the Oil Rent (as % of GDP) in Lithuania in 2013?
Provide a succinct answer. 0.83. What is the difference between the Oil Rent (as % of GDP) in High income in 2010 and the Oil Rent (as % of GDP) in Kuwait in 2013?
Your answer should be very brief. -55.45. What is the difference between the Oil Rent (as % of GDP) of High income in 2010 and the Oil Rent (as % of GDP) of Lithuania in 2013?
Offer a terse response. 1.9. What is the difference between the Oil Rent (as % of GDP) of Kuwait in 2010 and the Oil Rent (as % of GDP) of Lithuania in 2013?
Your answer should be very brief. 51.02. What is the difference between the Oil Rent (as % of GDP) of East Asia (all income levels) in 2011 and the Oil Rent (as % of GDP) of High income in 2012?
Ensure brevity in your answer.  -1.59. What is the difference between the Oil Rent (as % of GDP) of East Asia (all income levels) in 2011 and the Oil Rent (as % of GDP) of Kuwait in 2012?
Offer a terse response. -56.62. What is the difference between the Oil Rent (as % of GDP) of East Asia (all income levels) in 2011 and the Oil Rent (as % of GDP) of Lithuania in 2012?
Your response must be concise. 0.92. What is the difference between the Oil Rent (as % of GDP) in High income in 2011 and the Oil Rent (as % of GDP) in Kuwait in 2012?
Your response must be concise. -55.05. What is the difference between the Oil Rent (as % of GDP) in High income in 2011 and the Oil Rent (as % of GDP) in Lithuania in 2012?
Provide a succinct answer. 2.49. What is the difference between the Oil Rent (as % of GDP) in Kuwait in 2011 and the Oil Rent (as % of GDP) in Lithuania in 2012?
Your response must be concise. 58.44. What is the difference between the Oil Rent (as % of GDP) of East Asia (all income levels) in 2011 and the Oil Rent (as % of GDP) of High income in 2013?
Make the answer very short. -1.48. What is the difference between the Oil Rent (as % of GDP) in East Asia (all income levels) in 2011 and the Oil Rent (as % of GDP) in Kuwait in 2013?
Your answer should be very brief. -56.41. What is the difference between the Oil Rent (as % of GDP) in East Asia (all income levels) in 2011 and the Oil Rent (as % of GDP) in Lithuania in 2013?
Provide a short and direct response. 0.94. What is the difference between the Oil Rent (as % of GDP) of High income in 2011 and the Oil Rent (as % of GDP) of Kuwait in 2013?
Provide a short and direct response. -54.84. What is the difference between the Oil Rent (as % of GDP) in High income in 2011 and the Oil Rent (as % of GDP) in Lithuania in 2013?
Give a very brief answer. 2.51. What is the difference between the Oil Rent (as % of GDP) of Kuwait in 2011 and the Oil Rent (as % of GDP) of Lithuania in 2013?
Make the answer very short. 58.46. What is the difference between the Oil Rent (as % of GDP) of East Asia (all income levels) in 2012 and the Oil Rent (as % of GDP) of High income in 2013?
Offer a very short reply. -1.56. What is the difference between the Oil Rent (as % of GDP) of East Asia (all income levels) in 2012 and the Oil Rent (as % of GDP) of Kuwait in 2013?
Give a very brief answer. -56.49. What is the difference between the Oil Rent (as % of GDP) in East Asia (all income levels) in 2012 and the Oil Rent (as % of GDP) in Lithuania in 2013?
Your answer should be compact. 0.86. What is the difference between the Oil Rent (as % of GDP) in High income in 2012 and the Oil Rent (as % of GDP) in Kuwait in 2013?
Give a very brief answer. -54.82. What is the difference between the Oil Rent (as % of GDP) of High income in 2012 and the Oil Rent (as % of GDP) of Lithuania in 2013?
Offer a very short reply. 2.53. What is the difference between the Oil Rent (as % of GDP) in Kuwait in 2012 and the Oil Rent (as % of GDP) in Lithuania in 2013?
Ensure brevity in your answer.  57.56. What is the average Oil Rent (as % of GDP) of East Asia (all income levels) per year?
Keep it short and to the point. 1.09. What is the average Oil Rent (as % of GDP) in High income per year?
Give a very brief answer. 2.3. What is the average Oil Rent (as % of GDP) of Kuwait per year?
Provide a short and direct response. 54.54. What is the average Oil Rent (as % of GDP) of Lithuania per year?
Offer a very short reply. 0.16. In the year 2006, what is the difference between the Oil Rent (as % of GDP) in East Asia (all income levels) and Oil Rent (as % of GDP) in High income?
Keep it short and to the point. -0.89. In the year 2006, what is the difference between the Oil Rent (as % of GDP) in East Asia (all income levels) and Oil Rent (as % of GDP) in Kuwait?
Keep it short and to the point. -55.11. In the year 2006, what is the difference between the Oil Rent (as % of GDP) of East Asia (all income levels) and Oil Rent (as % of GDP) of Lithuania?
Your answer should be very brief. 1.01. In the year 2006, what is the difference between the Oil Rent (as % of GDP) in High income and Oil Rent (as % of GDP) in Kuwait?
Your response must be concise. -54.23. In the year 2006, what is the difference between the Oil Rent (as % of GDP) of High income and Oil Rent (as % of GDP) of Lithuania?
Provide a short and direct response. 1.9. In the year 2006, what is the difference between the Oil Rent (as % of GDP) of Kuwait and Oil Rent (as % of GDP) of Lithuania?
Provide a short and direct response. 56.12. In the year 2007, what is the difference between the Oil Rent (as % of GDP) in East Asia (all income levels) and Oil Rent (as % of GDP) in High income?
Offer a very short reply. -0.88. In the year 2007, what is the difference between the Oil Rent (as % of GDP) in East Asia (all income levels) and Oil Rent (as % of GDP) in Kuwait?
Your answer should be compact. -52.39. In the year 2007, what is the difference between the Oil Rent (as % of GDP) in East Asia (all income levels) and Oil Rent (as % of GDP) in Lithuania?
Make the answer very short. 1.05. In the year 2007, what is the difference between the Oil Rent (as % of GDP) of High income and Oil Rent (as % of GDP) of Kuwait?
Offer a very short reply. -51.5. In the year 2007, what is the difference between the Oil Rent (as % of GDP) in High income and Oil Rent (as % of GDP) in Lithuania?
Provide a succinct answer. 1.94. In the year 2007, what is the difference between the Oil Rent (as % of GDP) in Kuwait and Oil Rent (as % of GDP) in Lithuania?
Offer a very short reply. 53.44. In the year 2008, what is the difference between the Oil Rent (as % of GDP) in East Asia (all income levels) and Oil Rent (as % of GDP) in High income?
Make the answer very short. -1.23. In the year 2008, what is the difference between the Oil Rent (as % of GDP) of East Asia (all income levels) and Oil Rent (as % of GDP) of Kuwait?
Your response must be concise. -58.11. In the year 2008, what is the difference between the Oil Rent (as % of GDP) of East Asia (all income levels) and Oil Rent (as % of GDP) of Lithuania?
Offer a terse response. 1.33. In the year 2008, what is the difference between the Oil Rent (as % of GDP) in High income and Oil Rent (as % of GDP) in Kuwait?
Offer a very short reply. -56.88. In the year 2008, what is the difference between the Oil Rent (as % of GDP) in High income and Oil Rent (as % of GDP) in Lithuania?
Your answer should be very brief. 2.56. In the year 2008, what is the difference between the Oil Rent (as % of GDP) of Kuwait and Oil Rent (as % of GDP) of Lithuania?
Provide a succinct answer. 59.44. In the year 2009, what is the difference between the Oil Rent (as % of GDP) of East Asia (all income levels) and Oil Rent (as % of GDP) of High income?
Offer a terse response. -0.8. In the year 2009, what is the difference between the Oil Rent (as % of GDP) in East Asia (all income levels) and Oil Rent (as % of GDP) in Kuwait?
Keep it short and to the point. -41.05. In the year 2009, what is the difference between the Oil Rent (as % of GDP) of East Asia (all income levels) and Oil Rent (as % of GDP) of Lithuania?
Offer a terse response. 0.7. In the year 2009, what is the difference between the Oil Rent (as % of GDP) of High income and Oil Rent (as % of GDP) of Kuwait?
Make the answer very short. -40.25. In the year 2009, what is the difference between the Oil Rent (as % of GDP) of High income and Oil Rent (as % of GDP) of Lithuania?
Offer a very short reply. 1.49. In the year 2009, what is the difference between the Oil Rent (as % of GDP) in Kuwait and Oil Rent (as % of GDP) in Lithuania?
Make the answer very short. 41.74. In the year 2010, what is the difference between the Oil Rent (as % of GDP) of East Asia (all income levels) and Oil Rent (as % of GDP) of High income?
Provide a short and direct response. -1.07. In the year 2010, what is the difference between the Oil Rent (as % of GDP) in East Asia (all income levels) and Oil Rent (as % of GDP) in Kuwait?
Your response must be concise. -50.19. In the year 2010, what is the difference between the Oil Rent (as % of GDP) of East Asia (all income levels) and Oil Rent (as % of GDP) of Lithuania?
Ensure brevity in your answer.  0.81. In the year 2010, what is the difference between the Oil Rent (as % of GDP) in High income and Oil Rent (as % of GDP) in Kuwait?
Make the answer very short. -49.12. In the year 2010, what is the difference between the Oil Rent (as % of GDP) of High income and Oil Rent (as % of GDP) of Lithuania?
Ensure brevity in your answer.  1.88. In the year 2010, what is the difference between the Oil Rent (as % of GDP) in Kuwait and Oil Rent (as % of GDP) in Lithuania?
Offer a very short reply. 51. In the year 2011, what is the difference between the Oil Rent (as % of GDP) in East Asia (all income levels) and Oil Rent (as % of GDP) in High income?
Your answer should be compact. -1.57. In the year 2011, what is the difference between the Oil Rent (as % of GDP) of East Asia (all income levels) and Oil Rent (as % of GDP) of Kuwait?
Give a very brief answer. -57.52. In the year 2011, what is the difference between the Oil Rent (as % of GDP) of East Asia (all income levels) and Oil Rent (as % of GDP) of Lithuania?
Offer a very short reply. 0.9. In the year 2011, what is the difference between the Oil Rent (as % of GDP) of High income and Oil Rent (as % of GDP) of Kuwait?
Keep it short and to the point. -55.95. In the year 2011, what is the difference between the Oil Rent (as % of GDP) in High income and Oil Rent (as % of GDP) in Lithuania?
Your answer should be very brief. 2.48. In the year 2011, what is the difference between the Oil Rent (as % of GDP) of Kuwait and Oil Rent (as % of GDP) of Lithuania?
Provide a succinct answer. 58.42. In the year 2012, what is the difference between the Oil Rent (as % of GDP) of East Asia (all income levels) and Oil Rent (as % of GDP) of High income?
Your response must be concise. -1.67. In the year 2012, what is the difference between the Oil Rent (as % of GDP) of East Asia (all income levels) and Oil Rent (as % of GDP) of Kuwait?
Your answer should be very brief. -56.7. In the year 2012, what is the difference between the Oil Rent (as % of GDP) in East Asia (all income levels) and Oil Rent (as % of GDP) in Lithuania?
Your answer should be very brief. 0.84. In the year 2012, what is the difference between the Oil Rent (as % of GDP) in High income and Oil Rent (as % of GDP) in Kuwait?
Ensure brevity in your answer.  -55.03. In the year 2012, what is the difference between the Oil Rent (as % of GDP) of High income and Oil Rent (as % of GDP) of Lithuania?
Your answer should be compact. 2.51. In the year 2012, what is the difference between the Oil Rent (as % of GDP) of Kuwait and Oil Rent (as % of GDP) of Lithuania?
Your response must be concise. 57.54. In the year 2013, what is the difference between the Oil Rent (as % of GDP) in East Asia (all income levels) and Oil Rent (as % of GDP) in High income?
Offer a very short reply. -1.61. In the year 2013, what is the difference between the Oil Rent (as % of GDP) of East Asia (all income levels) and Oil Rent (as % of GDP) of Kuwait?
Offer a terse response. -56.54. In the year 2013, what is the difference between the Oil Rent (as % of GDP) in East Asia (all income levels) and Oil Rent (as % of GDP) in Lithuania?
Your answer should be compact. 0.81. In the year 2013, what is the difference between the Oil Rent (as % of GDP) in High income and Oil Rent (as % of GDP) in Kuwait?
Provide a short and direct response. -54.93. In the year 2013, what is the difference between the Oil Rent (as % of GDP) of High income and Oil Rent (as % of GDP) of Lithuania?
Your answer should be compact. 2.42. In the year 2013, what is the difference between the Oil Rent (as % of GDP) in Kuwait and Oil Rent (as % of GDP) in Lithuania?
Keep it short and to the point. 57.35. What is the ratio of the Oil Rent (as % of GDP) of East Asia (all income levels) in 2006 to that in 2007?
Provide a short and direct response. 1.02. What is the ratio of the Oil Rent (as % of GDP) in High income in 2006 to that in 2007?
Offer a terse response. 1.01. What is the ratio of the Oil Rent (as % of GDP) of Kuwait in 2006 to that in 2007?
Give a very brief answer. 1.05. What is the ratio of the Oil Rent (as % of GDP) in Lithuania in 2006 to that in 2007?
Ensure brevity in your answer.  1.41. What is the ratio of the Oil Rent (as % of GDP) in East Asia (all income levels) in 2006 to that in 2008?
Ensure brevity in your answer.  0.84. What is the ratio of the Oil Rent (as % of GDP) of High income in 2006 to that in 2008?
Your response must be concise. 0.78. What is the ratio of the Oil Rent (as % of GDP) of Kuwait in 2006 to that in 2008?
Make the answer very short. 0.95. What is the ratio of the Oil Rent (as % of GDP) of Lithuania in 2006 to that in 2008?
Ensure brevity in your answer.  1.48. What is the ratio of the Oil Rent (as % of GDP) in East Asia (all income levels) in 2006 to that in 2009?
Provide a succinct answer. 1.56. What is the ratio of the Oil Rent (as % of GDP) in High income in 2006 to that in 2009?
Your answer should be compact. 1.34. What is the ratio of the Oil Rent (as % of GDP) in Kuwait in 2006 to that in 2009?
Provide a succinct answer. 1.35. What is the ratio of the Oil Rent (as % of GDP) in Lithuania in 2006 to that in 2009?
Provide a succinct answer. 2.28. What is the ratio of the Oil Rent (as % of GDP) in East Asia (all income levels) in 2006 to that in 2010?
Offer a very short reply. 1.32. What is the ratio of the Oil Rent (as % of GDP) in High income in 2006 to that in 2010?
Your response must be concise. 1.06. What is the ratio of the Oil Rent (as % of GDP) in Kuwait in 2006 to that in 2010?
Give a very brief answer. 1.1. What is the ratio of the Oil Rent (as % of GDP) in Lithuania in 2006 to that in 2010?
Provide a short and direct response. 1.71. What is the ratio of the Oil Rent (as % of GDP) in East Asia (all income levels) in 2006 to that in 2011?
Keep it short and to the point. 1.17. What is the ratio of the Oil Rent (as % of GDP) of High income in 2006 to that in 2011?
Provide a succinct answer. 0.81. What is the ratio of the Oil Rent (as % of GDP) in Kuwait in 2006 to that in 2011?
Provide a short and direct response. 0.96. What is the ratio of the Oil Rent (as % of GDP) of Lithuania in 2006 to that in 2011?
Your response must be concise. 1.5. What is the ratio of the Oil Rent (as % of GDP) of East Asia (all income levels) in 2006 to that in 2012?
Ensure brevity in your answer.  1.27. What is the ratio of the Oil Rent (as % of GDP) in High income in 2006 to that in 2012?
Offer a terse response. 0.81. What is the ratio of the Oil Rent (as % of GDP) in Kuwait in 2006 to that in 2012?
Offer a terse response. 0.98. What is the ratio of the Oil Rent (as % of GDP) in Lithuania in 2006 to that in 2012?
Offer a very short reply. 1.7. What is the ratio of the Oil Rent (as % of GDP) in East Asia (all income levels) in 2006 to that in 2013?
Make the answer very short. 1.34. What is the ratio of the Oil Rent (as % of GDP) in High income in 2006 to that in 2013?
Offer a very short reply. 0.84. What is the ratio of the Oil Rent (as % of GDP) in Kuwait in 2006 to that in 2013?
Your answer should be very brief. 0.98. What is the ratio of the Oil Rent (as % of GDP) of Lithuania in 2006 to that in 2013?
Provide a short and direct response. 1.93. What is the ratio of the Oil Rent (as % of GDP) of East Asia (all income levels) in 2007 to that in 2008?
Offer a terse response. 0.82. What is the ratio of the Oil Rent (as % of GDP) of High income in 2007 to that in 2008?
Provide a short and direct response. 0.77. What is the ratio of the Oil Rent (as % of GDP) in Kuwait in 2007 to that in 2008?
Provide a short and direct response. 0.9. What is the ratio of the Oil Rent (as % of GDP) of Lithuania in 2007 to that in 2008?
Your answer should be very brief. 1.05. What is the ratio of the Oil Rent (as % of GDP) in East Asia (all income levels) in 2007 to that in 2009?
Provide a short and direct response. 1.53. What is the ratio of the Oil Rent (as % of GDP) in High income in 2007 to that in 2009?
Your answer should be compact. 1.32. What is the ratio of the Oil Rent (as % of GDP) of Kuwait in 2007 to that in 2009?
Offer a terse response. 1.28. What is the ratio of the Oil Rent (as % of GDP) in Lithuania in 2007 to that in 2009?
Your answer should be compact. 1.63. What is the ratio of the Oil Rent (as % of GDP) in East Asia (all income levels) in 2007 to that in 2010?
Give a very brief answer. 1.29. What is the ratio of the Oil Rent (as % of GDP) in High income in 2007 to that in 2010?
Give a very brief answer. 1.04. What is the ratio of the Oil Rent (as % of GDP) in Kuwait in 2007 to that in 2010?
Your response must be concise. 1.05. What is the ratio of the Oil Rent (as % of GDP) in Lithuania in 2007 to that in 2010?
Offer a terse response. 1.21. What is the ratio of the Oil Rent (as % of GDP) in East Asia (all income levels) in 2007 to that in 2011?
Offer a very short reply. 1.15. What is the ratio of the Oil Rent (as % of GDP) of High income in 2007 to that in 2011?
Make the answer very short. 0.8. What is the ratio of the Oil Rent (as % of GDP) in Kuwait in 2007 to that in 2011?
Your response must be concise. 0.92. What is the ratio of the Oil Rent (as % of GDP) in Lithuania in 2007 to that in 2011?
Provide a succinct answer. 1.07. What is the ratio of the Oil Rent (as % of GDP) in East Asia (all income levels) in 2007 to that in 2012?
Your answer should be compact. 1.25. What is the ratio of the Oil Rent (as % of GDP) in High income in 2007 to that in 2012?
Make the answer very short. 0.8. What is the ratio of the Oil Rent (as % of GDP) in Kuwait in 2007 to that in 2012?
Provide a short and direct response. 0.93. What is the ratio of the Oil Rent (as % of GDP) of Lithuania in 2007 to that in 2012?
Provide a short and direct response. 1.21. What is the ratio of the Oil Rent (as % of GDP) of East Asia (all income levels) in 2007 to that in 2013?
Offer a very short reply. 1.31. What is the ratio of the Oil Rent (as % of GDP) in High income in 2007 to that in 2013?
Provide a succinct answer. 0.83. What is the ratio of the Oil Rent (as % of GDP) in Kuwait in 2007 to that in 2013?
Your response must be concise. 0.93. What is the ratio of the Oil Rent (as % of GDP) of Lithuania in 2007 to that in 2013?
Your answer should be compact. 1.37. What is the ratio of the Oil Rent (as % of GDP) in East Asia (all income levels) in 2008 to that in 2009?
Provide a short and direct response. 1.87. What is the ratio of the Oil Rent (as % of GDP) in High income in 2008 to that in 2009?
Ensure brevity in your answer.  1.7. What is the ratio of the Oil Rent (as % of GDP) of Kuwait in 2008 to that in 2009?
Give a very brief answer. 1.42. What is the ratio of the Oil Rent (as % of GDP) of Lithuania in 2008 to that in 2009?
Keep it short and to the point. 1.55. What is the ratio of the Oil Rent (as % of GDP) of East Asia (all income levels) in 2008 to that in 2010?
Offer a very short reply. 1.57. What is the ratio of the Oil Rent (as % of GDP) in High income in 2008 to that in 2010?
Make the answer very short. 1.35. What is the ratio of the Oil Rent (as % of GDP) of Kuwait in 2008 to that in 2010?
Make the answer very short. 1.17. What is the ratio of the Oil Rent (as % of GDP) in Lithuania in 2008 to that in 2010?
Your answer should be compact. 1.15. What is the ratio of the Oil Rent (as % of GDP) of East Asia (all income levels) in 2008 to that in 2011?
Provide a succinct answer. 1.4. What is the ratio of the Oil Rent (as % of GDP) in High income in 2008 to that in 2011?
Make the answer very short. 1.03. What is the ratio of the Oil Rent (as % of GDP) in Kuwait in 2008 to that in 2011?
Offer a very short reply. 1.02. What is the ratio of the Oil Rent (as % of GDP) in Lithuania in 2008 to that in 2011?
Your response must be concise. 1.02. What is the ratio of the Oil Rent (as % of GDP) in East Asia (all income levels) in 2008 to that in 2012?
Give a very brief answer. 1.52. What is the ratio of the Oil Rent (as % of GDP) in Kuwait in 2008 to that in 2012?
Give a very brief answer. 1.03. What is the ratio of the Oil Rent (as % of GDP) of Lithuania in 2008 to that in 2012?
Your answer should be compact. 1.15. What is the ratio of the Oil Rent (as % of GDP) in East Asia (all income levels) in 2008 to that in 2013?
Your answer should be very brief. 1.61. What is the ratio of the Oil Rent (as % of GDP) of High income in 2008 to that in 2013?
Offer a very short reply. 1.07. What is the ratio of the Oil Rent (as % of GDP) of Kuwait in 2008 to that in 2013?
Offer a very short reply. 1.04. What is the ratio of the Oil Rent (as % of GDP) of Lithuania in 2008 to that in 2013?
Ensure brevity in your answer.  1.31. What is the ratio of the Oil Rent (as % of GDP) of East Asia (all income levels) in 2009 to that in 2010?
Give a very brief answer. 0.84. What is the ratio of the Oil Rent (as % of GDP) in High income in 2009 to that in 2010?
Offer a very short reply. 0.79. What is the ratio of the Oil Rent (as % of GDP) of Kuwait in 2009 to that in 2010?
Provide a short and direct response. 0.82. What is the ratio of the Oil Rent (as % of GDP) in Lithuania in 2009 to that in 2010?
Offer a terse response. 0.75. What is the ratio of the Oil Rent (as % of GDP) in East Asia (all income levels) in 2009 to that in 2011?
Ensure brevity in your answer.  0.75. What is the ratio of the Oil Rent (as % of GDP) of High income in 2009 to that in 2011?
Ensure brevity in your answer.  0.61. What is the ratio of the Oil Rent (as % of GDP) in Kuwait in 2009 to that in 2011?
Offer a terse response. 0.71. What is the ratio of the Oil Rent (as % of GDP) in Lithuania in 2009 to that in 2011?
Provide a short and direct response. 0.66. What is the ratio of the Oil Rent (as % of GDP) in East Asia (all income levels) in 2009 to that in 2012?
Provide a short and direct response. 0.82. What is the ratio of the Oil Rent (as % of GDP) in High income in 2009 to that in 2012?
Your answer should be compact. 0.6. What is the ratio of the Oil Rent (as % of GDP) of Kuwait in 2009 to that in 2012?
Your answer should be very brief. 0.73. What is the ratio of the Oil Rent (as % of GDP) in Lithuania in 2009 to that in 2012?
Give a very brief answer. 0.74. What is the ratio of the Oil Rent (as % of GDP) in East Asia (all income levels) in 2009 to that in 2013?
Your response must be concise. 0.86. What is the ratio of the Oil Rent (as % of GDP) of High income in 2009 to that in 2013?
Give a very brief answer. 0.63. What is the ratio of the Oil Rent (as % of GDP) in Kuwait in 2009 to that in 2013?
Offer a terse response. 0.73. What is the ratio of the Oil Rent (as % of GDP) of Lithuania in 2009 to that in 2013?
Your answer should be very brief. 0.85. What is the ratio of the Oil Rent (as % of GDP) of East Asia (all income levels) in 2010 to that in 2011?
Make the answer very short. 0.89. What is the ratio of the Oil Rent (as % of GDP) of High income in 2010 to that in 2011?
Offer a very short reply. 0.77. What is the ratio of the Oil Rent (as % of GDP) of Kuwait in 2010 to that in 2011?
Your answer should be compact. 0.87. What is the ratio of the Oil Rent (as % of GDP) in Lithuania in 2010 to that in 2011?
Ensure brevity in your answer.  0.88. What is the ratio of the Oil Rent (as % of GDP) of East Asia (all income levels) in 2010 to that in 2012?
Offer a terse response. 0.97. What is the ratio of the Oil Rent (as % of GDP) of High income in 2010 to that in 2012?
Your answer should be very brief. 0.76. What is the ratio of the Oil Rent (as % of GDP) of Kuwait in 2010 to that in 2012?
Provide a short and direct response. 0.89. What is the ratio of the Oil Rent (as % of GDP) of East Asia (all income levels) in 2010 to that in 2013?
Your response must be concise. 1.02. What is the ratio of the Oil Rent (as % of GDP) of High income in 2010 to that in 2013?
Ensure brevity in your answer.  0.8. What is the ratio of the Oil Rent (as % of GDP) in Kuwait in 2010 to that in 2013?
Provide a succinct answer. 0.89. What is the ratio of the Oil Rent (as % of GDP) in Lithuania in 2010 to that in 2013?
Provide a succinct answer. 1.13. What is the ratio of the Oil Rent (as % of GDP) of East Asia (all income levels) in 2011 to that in 2012?
Make the answer very short. 1.08. What is the ratio of the Oil Rent (as % of GDP) of Kuwait in 2011 to that in 2012?
Your response must be concise. 1.02. What is the ratio of the Oil Rent (as % of GDP) in Lithuania in 2011 to that in 2012?
Provide a succinct answer. 1.13. What is the ratio of the Oil Rent (as % of GDP) of East Asia (all income levels) in 2011 to that in 2013?
Keep it short and to the point. 1.14. What is the ratio of the Oil Rent (as % of GDP) in High income in 2011 to that in 2013?
Offer a terse response. 1.04. What is the ratio of the Oil Rent (as % of GDP) of Kuwait in 2011 to that in 2013?
Give a very brief answer. 1.02. What is the ratio of the Oil Rent (as % of GDP) of Lithuania in 2011 to that in 2013?
Offer a very short reply. 1.29. What is the ratio of the Oil Rent (as % of GDP) of East Asia (all income levels) in 2012 to that in 2013?
Make the answer very short. 1.06. What is the ratio of the Oil Rent (as % of GDP) in High income in 2012 to that in 2013?
Your answer should be compact. 1.04. What is the ratio of the Oil Rent (as % of GDP) of Kuwait in 2012 to that in 2013?
Provide a short and direct response. 1. What is the ratio of the Oil Rent (as % of GDP) of Lithuania in 2012 to that in 2013?
Your answer should be compact. 1.14. What is the difference between the highest and the second highest Oil Rent (as % of GDP) of East Asia (all income levels)?
Your answer should be very brief. 0.24. What is the difference between the highest and the second highest Oil Rent (as % of GDP) of High income?
Keep it short and to the point. 0.07. What is the difference between the highest and the second highest Oil Rent (as % of GDP) in Kuwait?
Make the answer very short. 1.02. What is the difference between the highest and the second highest Oil Rent (as % of GDP) in Lithuania?
Offer a very short reply. 0.07. What is the difference between the highest and the lowest Oil Rent (as % of GDP) of East Asia (all income levels)?
Your response must be concise. 0.69. What is the difference between the highest and the lowest Oil Rent (as % of GDP) in High income?
Offer a very short reply. 1.13. What is the difference between the highest and the lowest Oil Rent (as % of GDP) of Kuwait?
Your answer should be very brief. 17.76. What is the difference between the highest and the lowest Oil Rent (as % of GDP) of Lithuania?
Give a very brief answer. 0.14. 